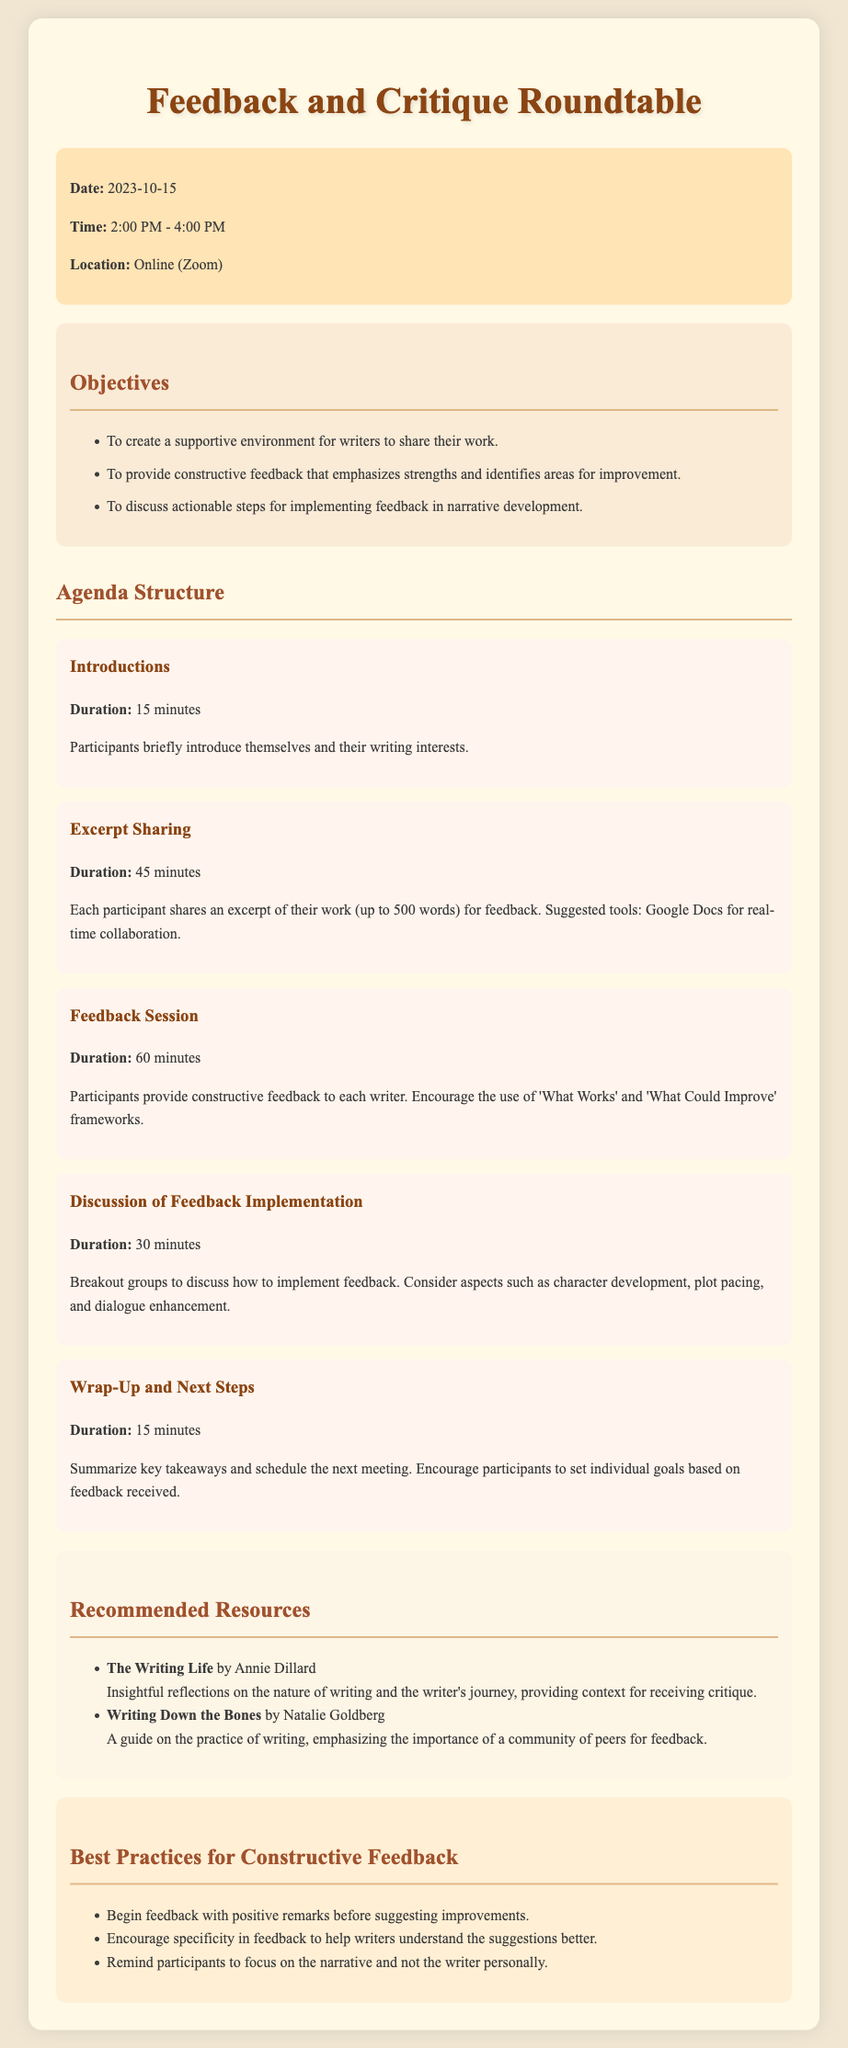what is the date of the event? The date of the event is explicitly stated in the document.
Answer: 2023-10-15 what is the duration of the Feedback Session? The document specifies the duration for each agenda item, including the Feedback Session.
Answer: 60 minutes what is one of the objectives of the roundtable? The objectives are listed in the document, and one example is directly mentioned.
Answer: To create a supportive environment for writers to share their work how long is the Excerpt Sharing segment? The document outlines the time allotted for each item in the agenda, including Excerpt Sharing.
Answer: 45 minutes what platform will the meeting take place on? The location of the event is mentioned clearly in the document.
Answer: Online (Zoom) what are the best practices for constructive feedback? The document lists important practices, with a notable example included.
Answer: Begin feedback with positive remarks before suggesting improvements what will participants discuss in breakout groups? The document specifies the topics that will be discussed during the breakout group session.
Answer: How to implement feedback how many recommended resources are listed? The document includes a list of resources and their count is relevant to this question.
Answer: 2 what is included in the Wrap-Up and Next Steps segment? The content of the Wrap-Up and Next Steps section is described in the agenda.
Answer: Summarize key takeaways and schedule the next meeting 